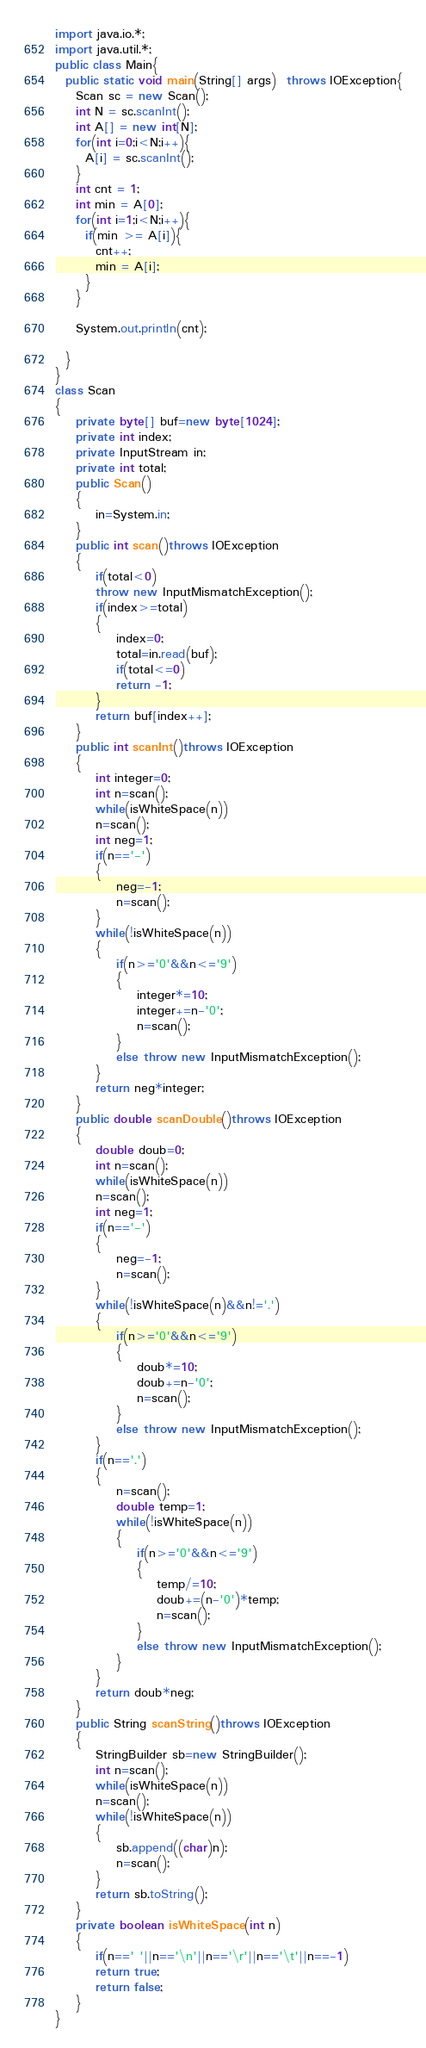<code> <loc_0><loc_0><loc_500><loc_500><_Java_>import java.io.*;
import java.util.*;
public class Main{
  public static void main(String[] args)  throws IOException{
    Scan sc = new Scan();
    int N = sc.scanInt();
    int A[] = new int[N];
    for(int i=0;i<N;i++){
      A[i] = sc.scanInt();
    }
    int cnt = 1;
    int min = A[0];
    for(int i=1;i<N;i++){
      if(min >= A[i]){
        cnt++;
        min = A[i];
      }
    }

    System.out.println(cnt);

  }
}
class Scan
{
    private byte[] buf=new byte[1024];
    private int index;
    private InputStream in;
    private int total;
    public Scan()
    {
        in=System.in;
    }
    public int scan()throws IOException
    {
        if(total<0)
        throw new InputMismatchException();
        if(index>=total)
        {
            index=0;
            total=in.read(buf);
            if(total<=0)
            return -1;
        }
        return buf[index++];
    }
    public int scanInt()throws IOException
    {
        int integer=0;
        int n=scan();
        while(isWhiteSpace(n))
        n=scan();
        int neg=1;
        if(n=='-')
        {
            neg=-1;
            n=scan();
        }
        while(!isWhiteSpace(n))
        {
            if(n>='0'&&n<='9')
            {
                integer*=10;
                integer+=n-'0';
                n=scan();
            }
            else throw new InputMismatchException();
        }
        return neg*integer;
    }
    public double scanDouble()throws IOException
    {
        double doub=0;
        int n=scan();
        while(isWhiteSpace(n))
        n=scan();
        int neg=1;
        if(n=='-')
        {
            neg=-1;
            n=scan();
        }
        while(!isWhiteSpace(n)&&n!='.')
        {
            if(n>='0'&&n<='9')
            {
                doub*=10;
                doub+=n-'0';
                n=scan();
            }
            else throw new InputMismatchException();
        }
        if(n=='.')
        {
            n=scan();
            double temp=1;
            while(!isWhiteSpace(n))
            {
                if(n>='0'&&n<='9')
                {
                    temp/=10;
                    doub+=(n-'0')*temp;
                    n=scan();
                }
                else throw new InputMismatchException();
            }
        }
        return doub*neg;
    }
    public String scanString()throws IOException
    {
        StringBuilder sb=new StringBuilder();
        int n=scan();
        while(isWhiteSpace(n))
        n=scan();
        while(!isWhiteSpace(n))
        {
            sb.append((char)n);
            n=scan();
        }
        return sb.toString();
    }
    private boolean isWhiteSpace(int n)
    {
        if(n==' '||n=='\n'||n=='\r'||n=='\t'||n==-1)
        return true;
        return false;
    }
}
</code> 